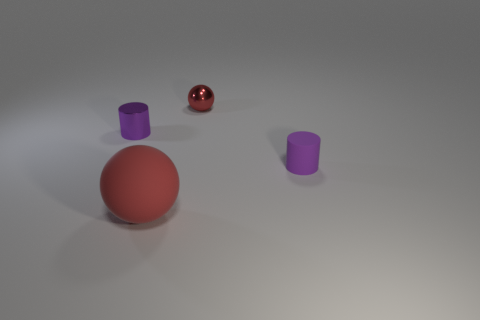Add 1 red things. How many objects exist? 5 Subtract 1 balls. How many balls are left? 1 Subtract all red matte balls. Subtract all brown metal cubes. How many objects are left? 3 Add 3 tiny metallic objects. How many tiny metallic objects are left? 5 Add 2 green matte cylinders. How many green matte cylinders exist? 2 Subtract 0 gray balls. How many objects are left? 4 Subtract all brown spheres. Subtract all purple cylinders. How many spheres are left? 2 